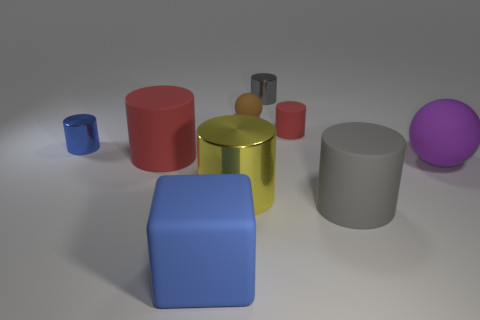Are there any other things that are the same shape as the large purple object? Yes, there are multiple objects in the image that share the same cylindrical shape as the large purple object, including a smaller golden cylinder and a few other items with similar curved edges and circular bases. 